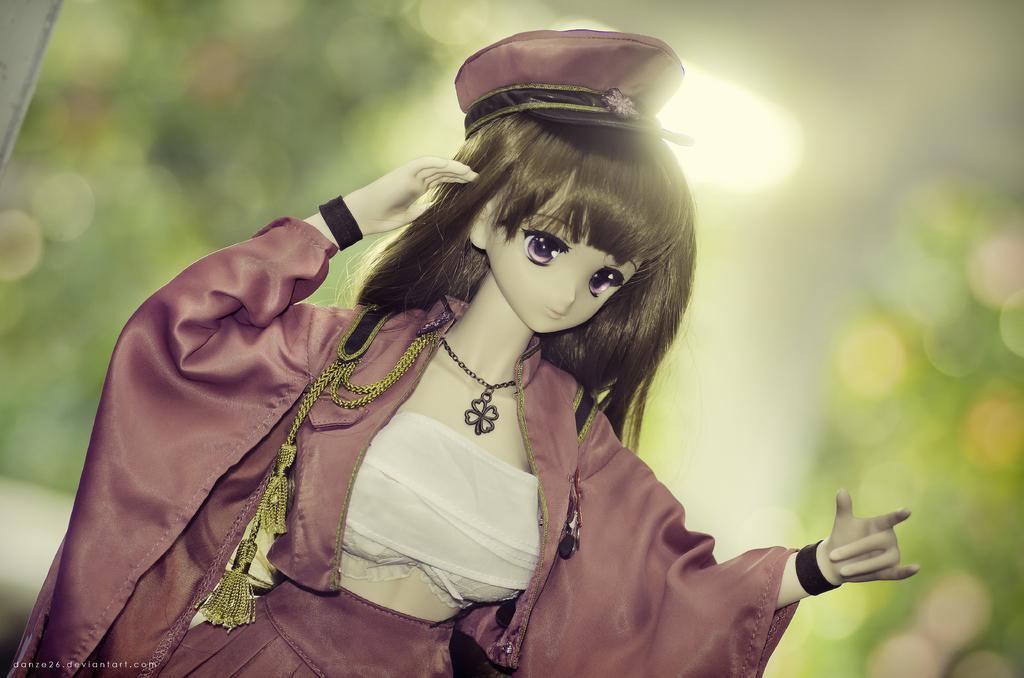In one or two sentences, can you explain what this image depicts? In this picture I can see a toy of a woman. On the toy I can see a cap and clothes. The background of the image is blurred. 